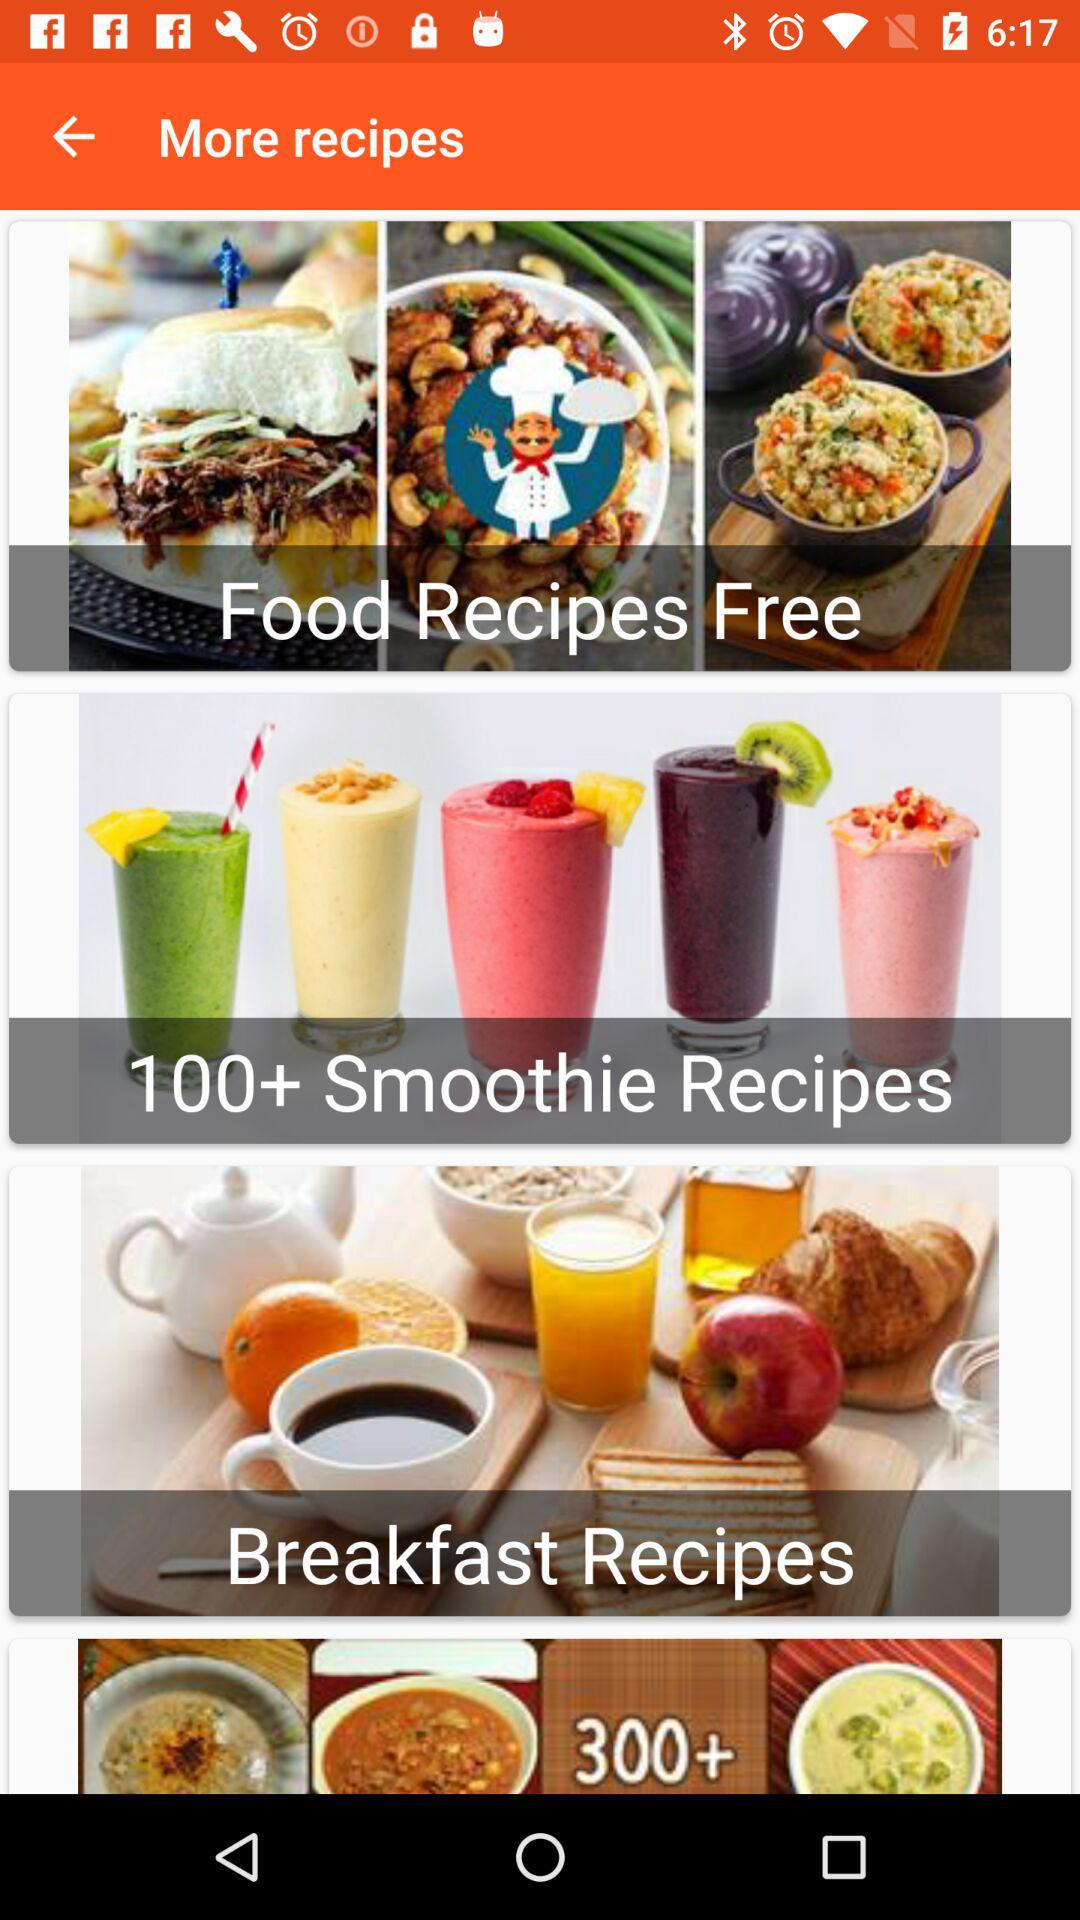How many smoothie recipes are there? There are "100+" smoothie recipes. 